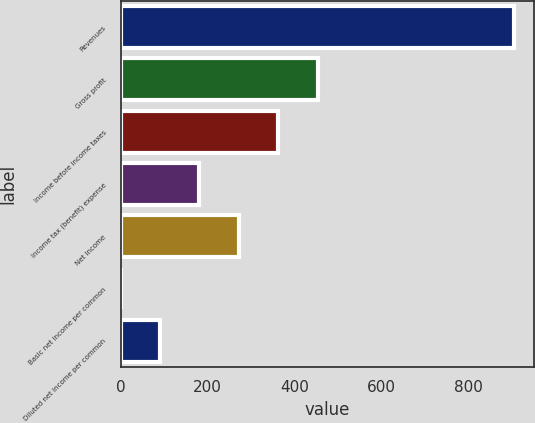Convert chart to OTSL. <chart><loc_0><loc_0><loc_500><loc_500><bar_chart><fcel>Revenues<fcel>Gross profit<fcel>Income before income taxes<fcel>Income tax (benefit) expense<fcel>Net income<fcel>Basic net income per common<fcel>Diluted net income per common<nl><fcel>906.6<fcel>453.34<fcel>362.69<fcel>181.39<fcel>272.04<fcel>0.09<fcel>90.74<nl></chart> 